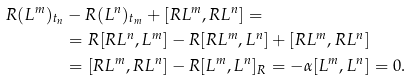<formula> <loc_0><loc_0><loc_500><loc_500>R ( L ^ { m } ) _ { t _ { n } } & - R ( L ^ { n } ) _ { t _ { m } } + [ R L ^ { m } , R L ^ { n } ] = \\ & = R [ R L ^ { n } , L ^ { m } ] - R [ R L ^ { m } , L ^ { n } ] + [ R L ^ { m } , R L ^ { n } ] \\ & = [ R L ^ { m } , R L ^ { n } ] - R [ L ^ { m } , L ^ { n } ] _ { R } = - \alpha [ L ^ { m } , L ^ { n } ] = 0 .</formula> 